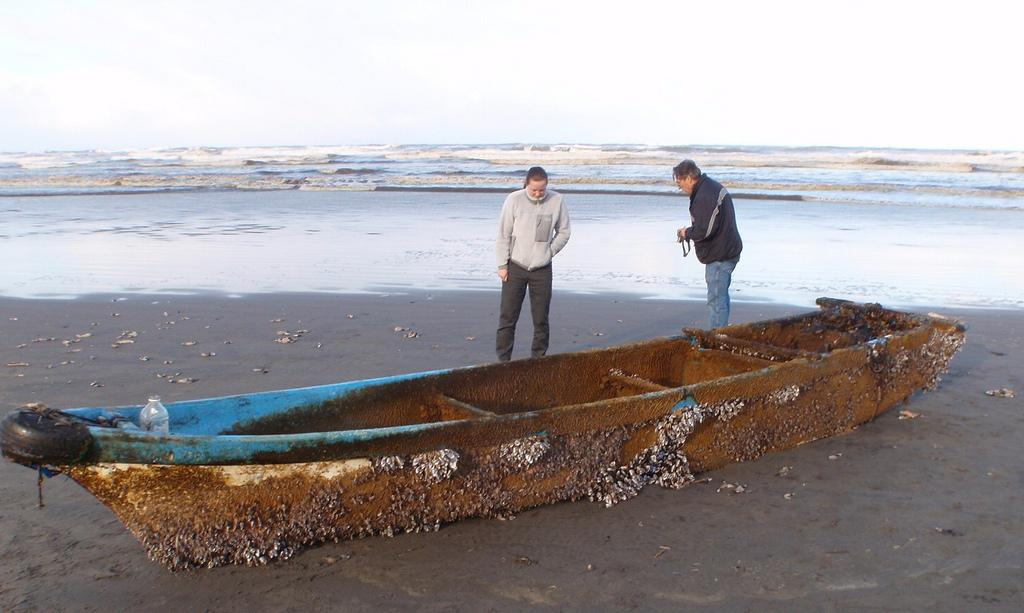How many people are in the image? There are two persons standing in the image. What is the setting of the image? The surface of water is visible in the image. What is located at the bottom of the image? There is a boat at the bottom of the image. What can be seen in the background of the image? The sky is visible in the background of the image. Where is the dog sitting in the image? There is no dog present in the image. What type of food is being served in the lunchroom in the image? There is no lunchroom present in the image. 